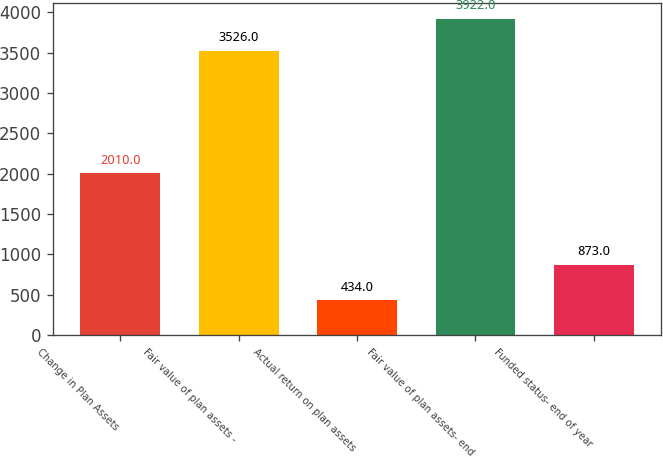Convert chart to OTSL. <chart><loc_0><loc_0><loc_500><loc_500><bar_chart><fcel>Change in Plan Assets<fcel>Fair value of plan assets -<fcel>Actual return on plan assets<fcel>Fair value of plan assets- end<fcel>Funded status- end of year<nl><fcel>2010<fcel>3526<fcel>434<fcel>3922<fcel>873<nl></chart> 